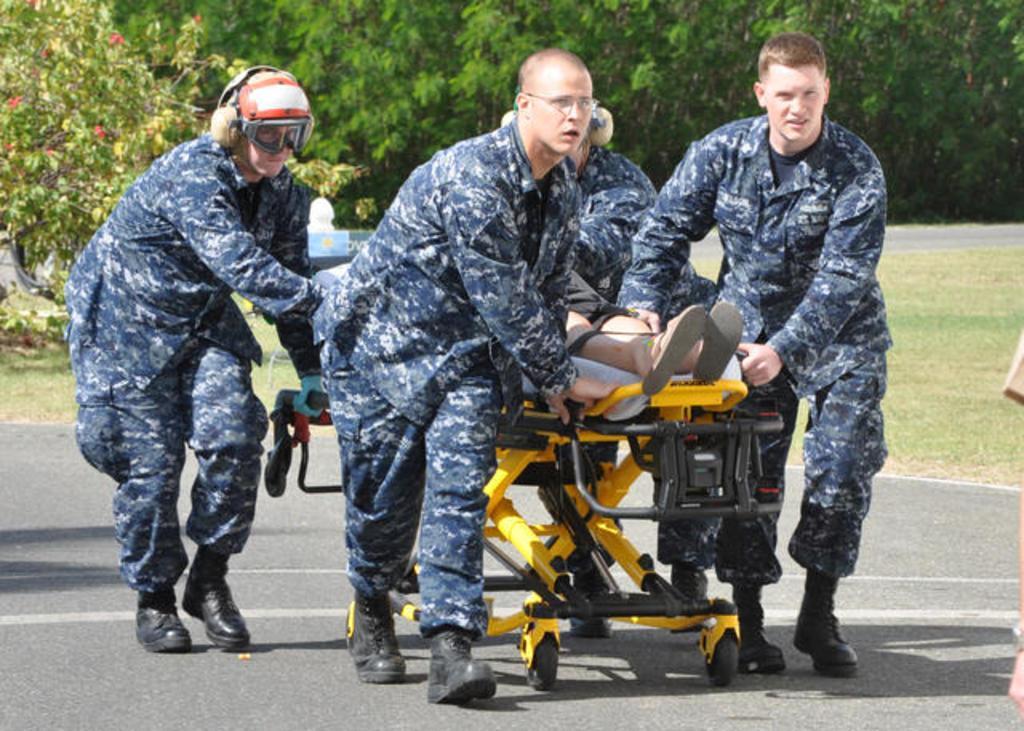Could you give a brief overview of what you see in this image? In this image there are four persons who are holding stretcher and walk in, and on the stretcher there is one person who is sleeping. In the background there are some trees, at the bottom there is grass and road. 